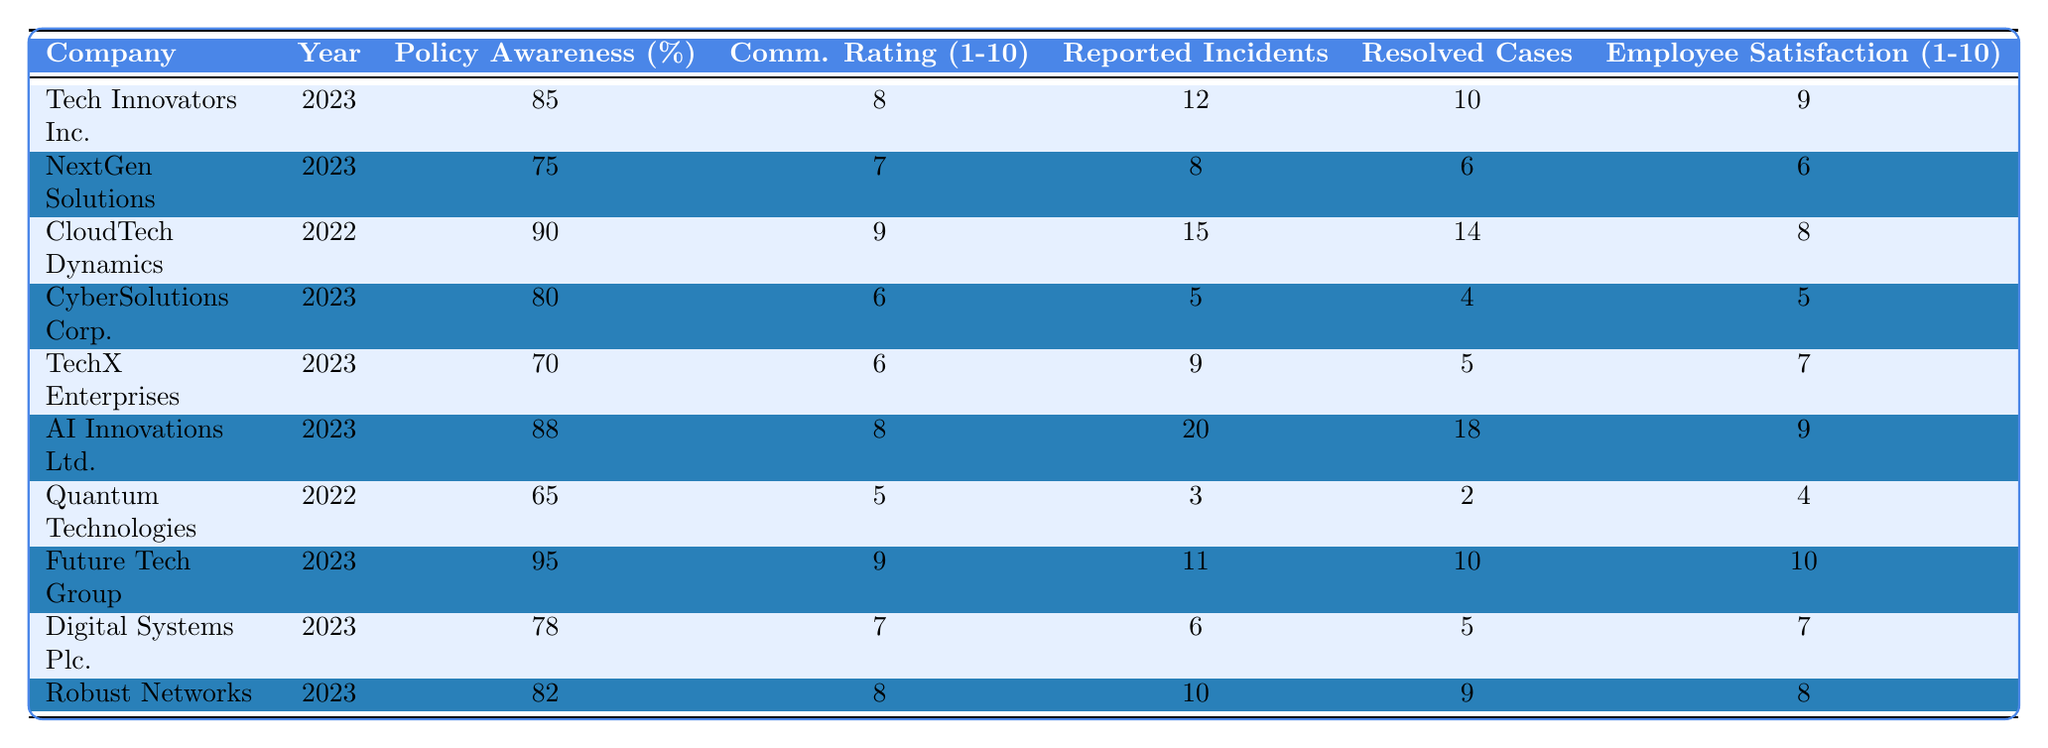What is the highest whistleblower policy awareness percentage? Looking through the table, Future Tech Group has the highest awareness at 95%.
Answer: 95% Which company reported the highest number of incidents? AI Innovations Ltd. reported the highest number of incidents at 20.
Answer: 20 What is the average employee satisfaction rating of all companies in 2023? Adding the ratings for 2023: (9 + 6 + 5 + 7 + 9 + 10 + 7 + 8) = 61. There are 8 companies, so the average is 61/8 = 7.625, rounded to 7.6.
Answer: 7.6 Did Quantum Technologies have a communication rating higher than CyberSolutions Corp.? Quantum Technologies has a communication rating of 5, while CyberSolutions Corp. has 6, so Quantum Technologies did not have a higher rating.
Answer: No What is the total number of reported incidents and resolved cases for Tech Innovators Inc.? Tech Innovators Inc. reported 12 incidents and had 10 resolved cases, so the total is 12 + 10 = 22.
Answer: 22 Which company had the lowest employee satisfaction rating, and what was that rating? Quantum Technologies had the lowest satisfaction rating at 4.
Answer: 4 Is there a positive correlation between the whistleblower policy awareness percentage and the internal communication rating? The general trend shows that higher awareness percentages tend to correlate with higher communication ratings, but a correlation analysis would be necessary for a definitive answer.
Answer: Yes How many companies reported 10 or more resolved cases? Reviewing the table, Tech Innovators Inc. (10), AI Innovations Ltd. (18), and Future Tech Group (10) reported 10 or more resolved cases, totaling 3 companies.
Answer: 3 What percentage of reported incidents were resolved by AI Innovations Ltd.? AI Innovations Ltd. reported 20 incidents and resolved 18, so the percentage is (18/20) * 100 = 90%.
Answer: 90% Compare the whistleblower policy awareness of CloudTech Dynamics and NextGen Solutions. CloudTech Dynamics has 90% awareness, while NextGen Solutions has 75%, meaning CloudTech Dynamics has higher awareness.
Answer: Higher for CloudTech Dynamics 